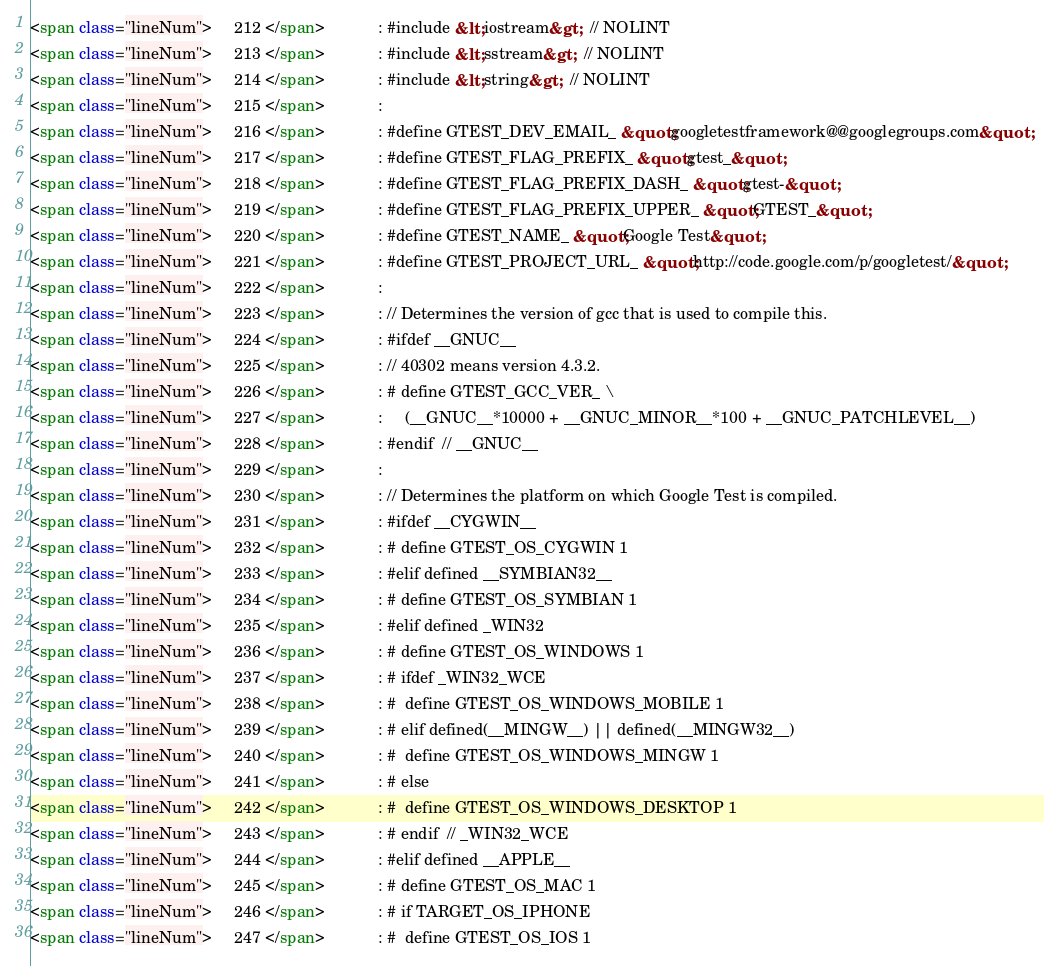Convert code to text. <code><loc_0><loc_0><loc_500><loc_500><_HTML_><span class="lineNum">     212 </span>            : #include &lt;iostream&gt;  // NOLINT
<span class="lineNum">     213 </span>            : #include &lt;sstream&gt;  // NOLINT
<span class="lineNum">     214 </span>            : #include &lt;string&gt;  // NOLINT
<span class="lineNum">     215 </span>            : 
<span class="lineNum">     216 </span>            : #define GTEST_DEV_EMAIL_ &quot;googletestframework@@googlegroups.com&quot;
<span class="lineNum">     217 </span>            : #define GTEST_FLAG_PREFIX_ &quot;gtest_&quot;
<span class="lineNum">     218 </span>            : #define GTEST_FLAG_PREFIX_DASH_ &quot;gtest-&quot;
<span class="lineNum">     219 </span>            : #define GTEST_FLAG_PREFIX_UPPER_ &quot;GTEST_&quot;
<span class="lineNum">     220 </span>            : #define GTEST_NAME_ &quot;Google Test&quot;
<span class="lineNum">     221 </span>            : #define GTEST_PROJECT_URL_ &quot;http://code.google.com/p/googletest/&quot;
<span class="lineNum">     222 </span>            : 
<span class="lineNum">     223 </span>            : // Determines the version of gcc that is used to compile this.
<span class="lineNum">     224 </span>            : #ifdef __GNUC__
<span class="lineNum">     225 </span>            : // 40302 means version 4.3.2.
<span class="lineNum">     226 </span>            : # define GTEST_GCC_VER_ \
<span class="lineNum">     227 </span>            :     (__GNUC__*10000 + __GNUC_MINOR__*100 + __GNUC_PATCHLEVEL__)
<span class="lineNum">     228 </span>            : #endif  // __GNUC__
<span class="lineNum">     229 </span>            : 
<span class="lineNum">     230 </span>            : // Determines the platform on which Google Test is compiled.
<span class="lineNum">     231 </span>            : #ifdef __CYGWIN__
<span class="lineNum">     232 </span>            : # define GTEST_OS_CYGWIN 1
<span class="lineNum">     233 </span>            : #elif defined __SYMBIAN32__
<span class="lineNum">     234 </span>            : # define GTEST_OS_SYMBIAN 1
<span class="lineNum">     235 </span>            : #elif defined _WIN32
<span class="lineNum">     236 </span>            : # define GTEST_OS_WINDOWS 1
<span class="lineNum">     237 </span>            : # ifdef _WIN32_WCE
<span class="lineNum">     238 </span>            : #  define GTEST_OS_WINDOWS_MOBILE 1
<span class="lineNum">     239 </span>            : # elif defined(__MINGW__) || defined(__MINGW32__)
<span class="lineNum">     240 </span>            : #  define GTEST_OS_WINDOWS_MINGW 1
<span class="lineNum">     241 </span>            : # else
<span class="lineNum">     242 </span>            : #  define GTEST_OS_WINDOWS_DESKTOP 1
<span class="lineNum">     243 </span>            : # endif  // _WIN32_WCE
<span class="lineNum">     244 </span>            : #elif defined __APPLE__
<span class="lineNum">     245 </span>            : # define GTEST_OS_MAC 1
<span class="lineNum">     246 </span>            : # if TARGET_OS_IPHONE
<span class="lineNum">     247 </span>            : #  define GTEST_OS_IOS 1</code> 